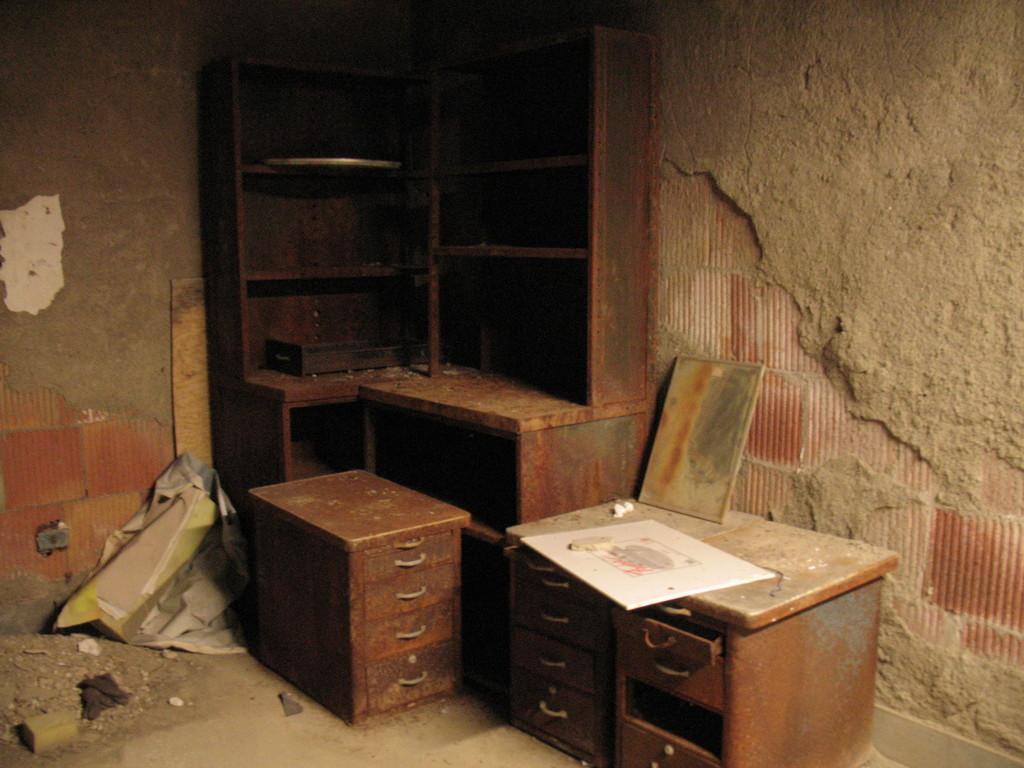Could you give a brief overview of what you see in this image? In this image I see the wall, cabinets and the tables and I can also see the mud over here. 